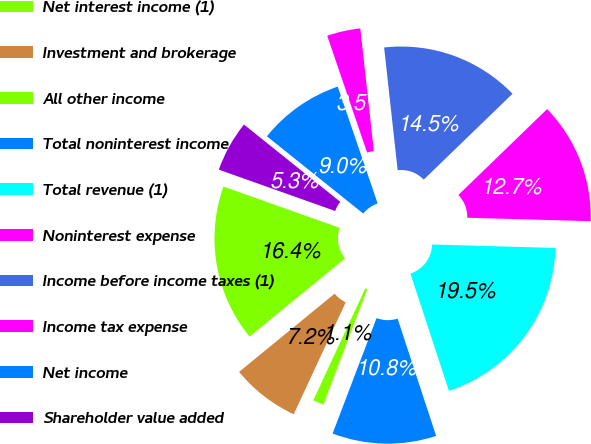Convert chart to OTSL. <chart><loc_0><loc_0><loc_500><loc_500><pie_chart><fcel>Net interest income (1)<fcel>Investment and brokerage<fcel>All other income<fcel>Total noninterest income<fcel>Total revenue (1)<fcel>Noninterest expense<fcel>Income before income taxes (1)<fcel>Income tax expense<fcel>Net income<fcel>Shareholder value added<nl><fcel>16.35%<fcel>7.16%<fcel>1.13%<fcel>10.84%<fcel>19.51%<fcel>12.68%<fcel>14.51%<fcel>3.49%<fcel>9.0%<fcel>5.33%<nl></chart> 